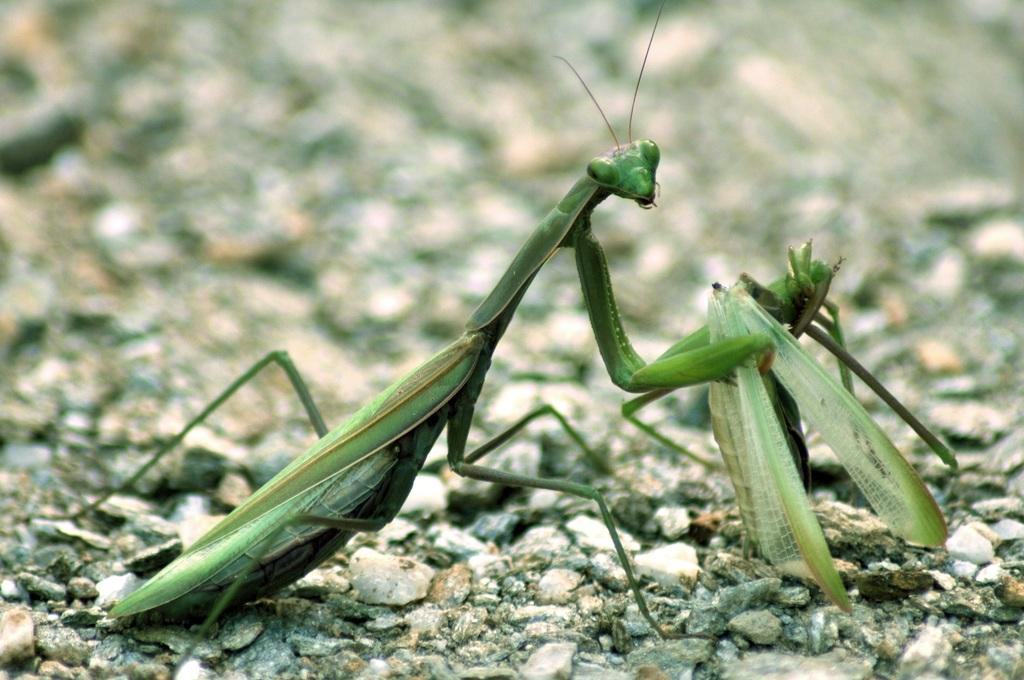How many insects are present in the image? There are two insects in the image. What color are the insects? The insects are green in color. Where are the insects located in the image? The insects are on the ground. Can you describe the background of the image? The background of the image is blurry. What grade of canvas is used for the background of the image? There is no canvas present in the image, and therefore no grade of canvas can be determined. 